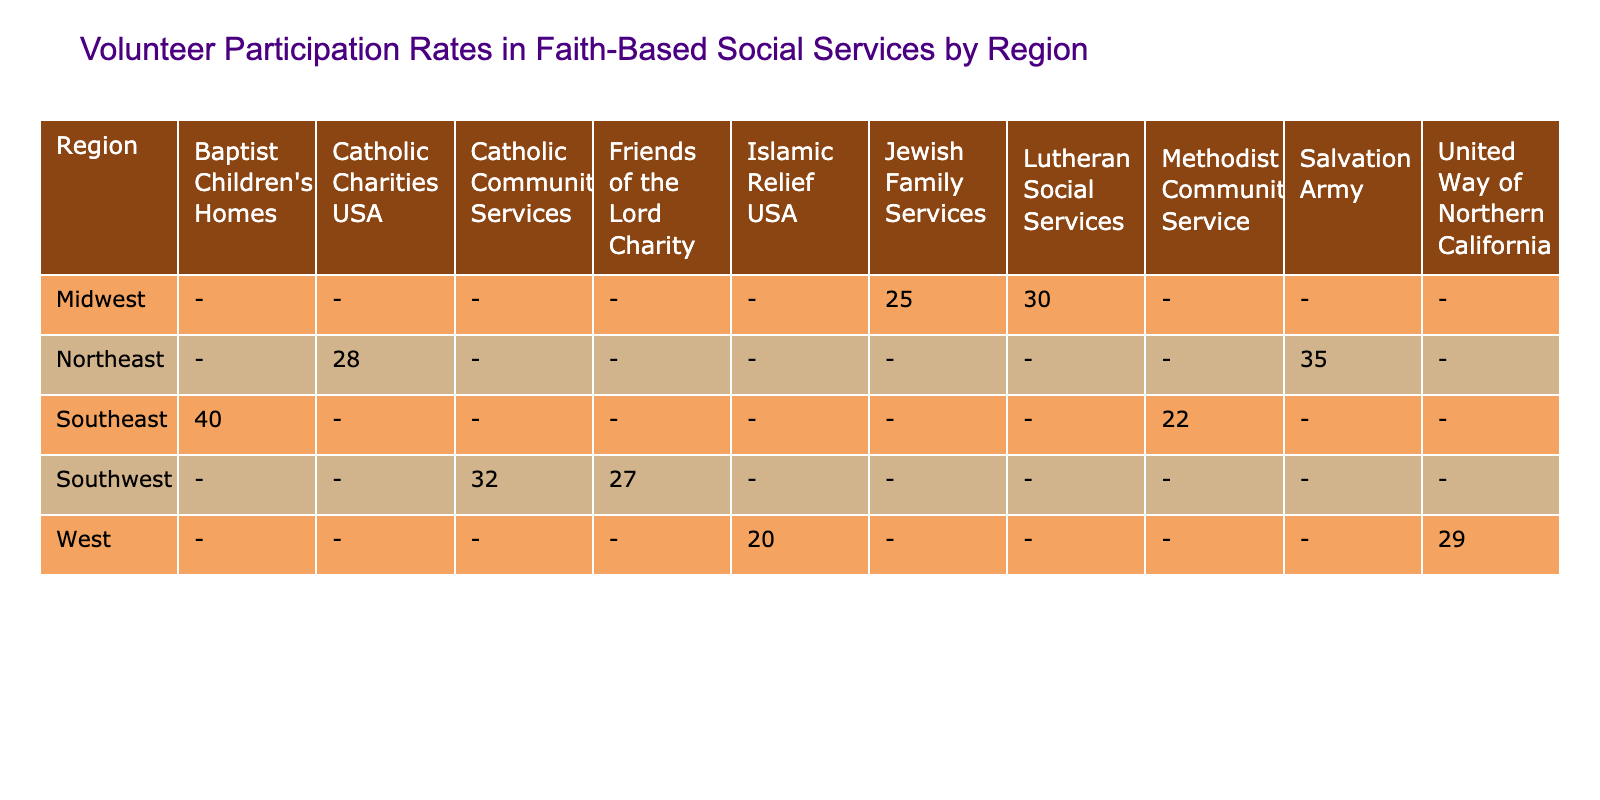What is the volunteer participation rate of the Salvation Army in the Northeast region? The table shows that the Salvation Army has a volunteer participation rate of 35% in the Northeast region.
Answer: 35% Which faith-based organization has the highest volunteer participation rate in the Southeast region? According to the table, Baptist Children's Homes has the highest volunteer participation rate in the Southeast at 40%.
Answer: 40% What is the average volunteer participation rate of organizations in the Midwest region? The volunteer participation rates for the Midwest organizations are 30% (Lutheran Social Services) and 25% (Jewish Family Services). Adding these gives 30 + 25 = 55%. Dividing by the number of organizations (2) yields an average of 55 / 2 = 27.5%.
Answer: 27.5% Is the participation rate of the Islamic Relief USA in the West region higher than 25%? The table states that the participation rate for Islamic Relief USA is 20%, which is below 25%. Therefore, the answer is no.
Answer: No What is the difference in volunteer participation rates between the highest and lowest rated organizations in the table? The highest rate is 40% (Baptist Children's Homes), and the lowest is 20% (Islamic Relief USA). Calculating the difference gives 40 - 20 = 20%.
Answer: 20% Which region has a volunteer participation rate of 32%? The Southwest region shows a volunteer participation rate of 32% for Catholic Community Services as per the table.
Answer: 32% Does the Northeast region have any organization with a participation rate of 30% or more? Yes, both the Salvation Army (35%) and Catholic Charities USA (28%) in the Northeast show participation rates of 30% or higher.
Answer: Yes What is the total volunteer participation rate when adding the rates from the Southeast organizations? The rates from the Southeast organizations are 40% (Baptist Children's Homes) and 22% (Methodist Community Service). Adding them gives 40 + 22 = 62%.
Answer: 62% What organization in the Southwest has a higher volunteer participation rate, Friends of the Lord Charity or Catholic Community Services? A comparison of the rates reveals that Catholic Community Services has a rate of 32% while Friends of the Lord Charity has a rate of 27%. Thus, Catholic Community Services has a higher rate.
Answer: Catholic Community Services 